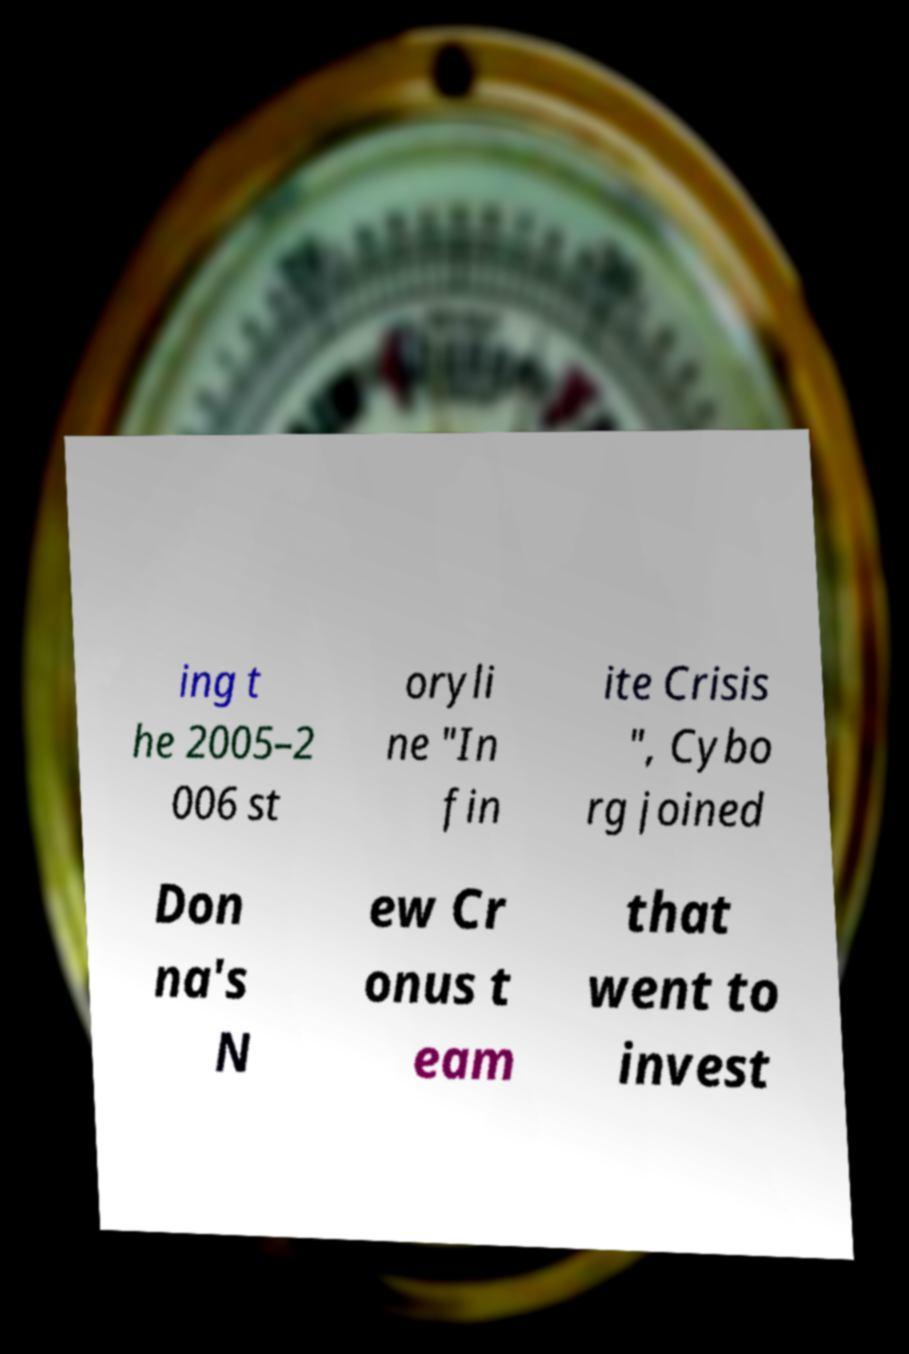For documentation purposes, I need the text within this image transcribed. Could you provide that? ing t he 2005–2 006 st oryli ne "In fin ite Crisis ", Cybo rg joined Don na's N ew Cr onus t eam that went to invest 